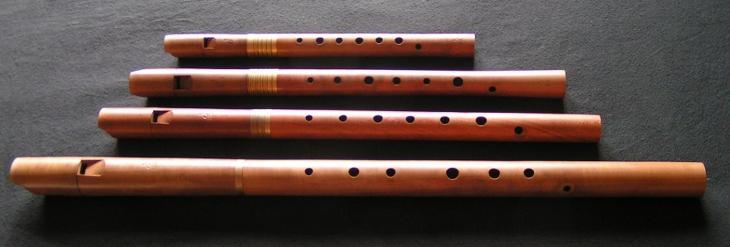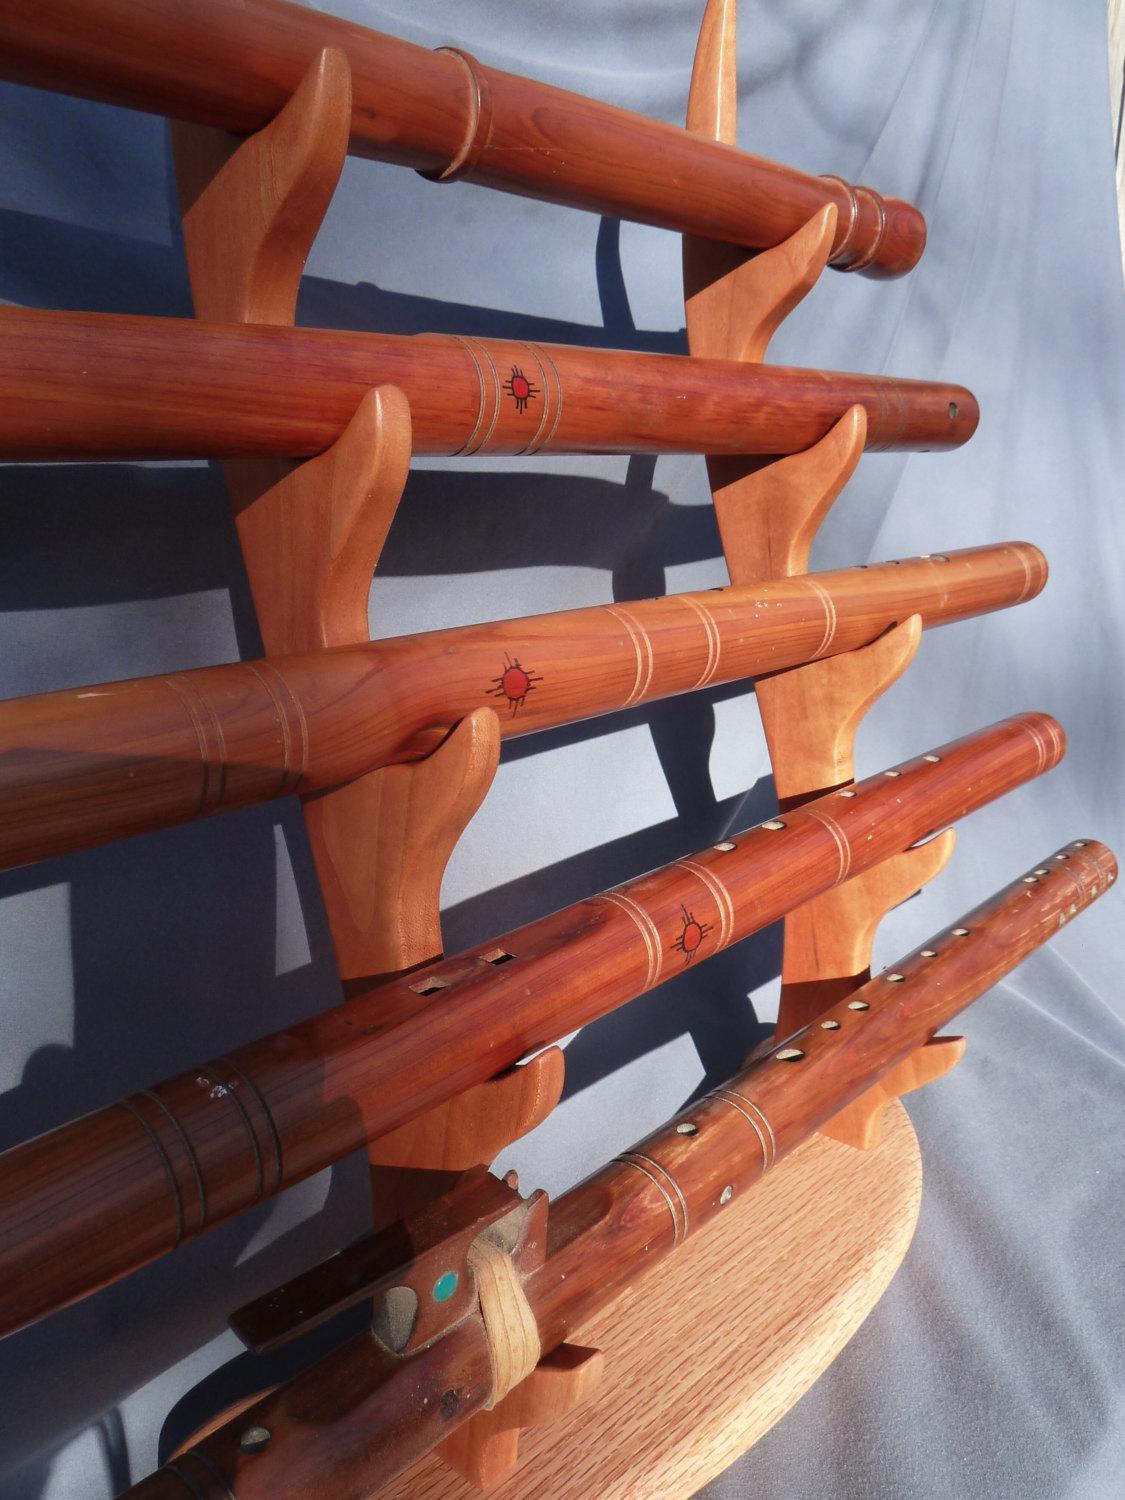The first image is the image on the left, the second image is the image on the right. Examine the images to the left and right. Is the description "There are more instruments in the image on the right." accurate? Answer yes or no. Yes. 